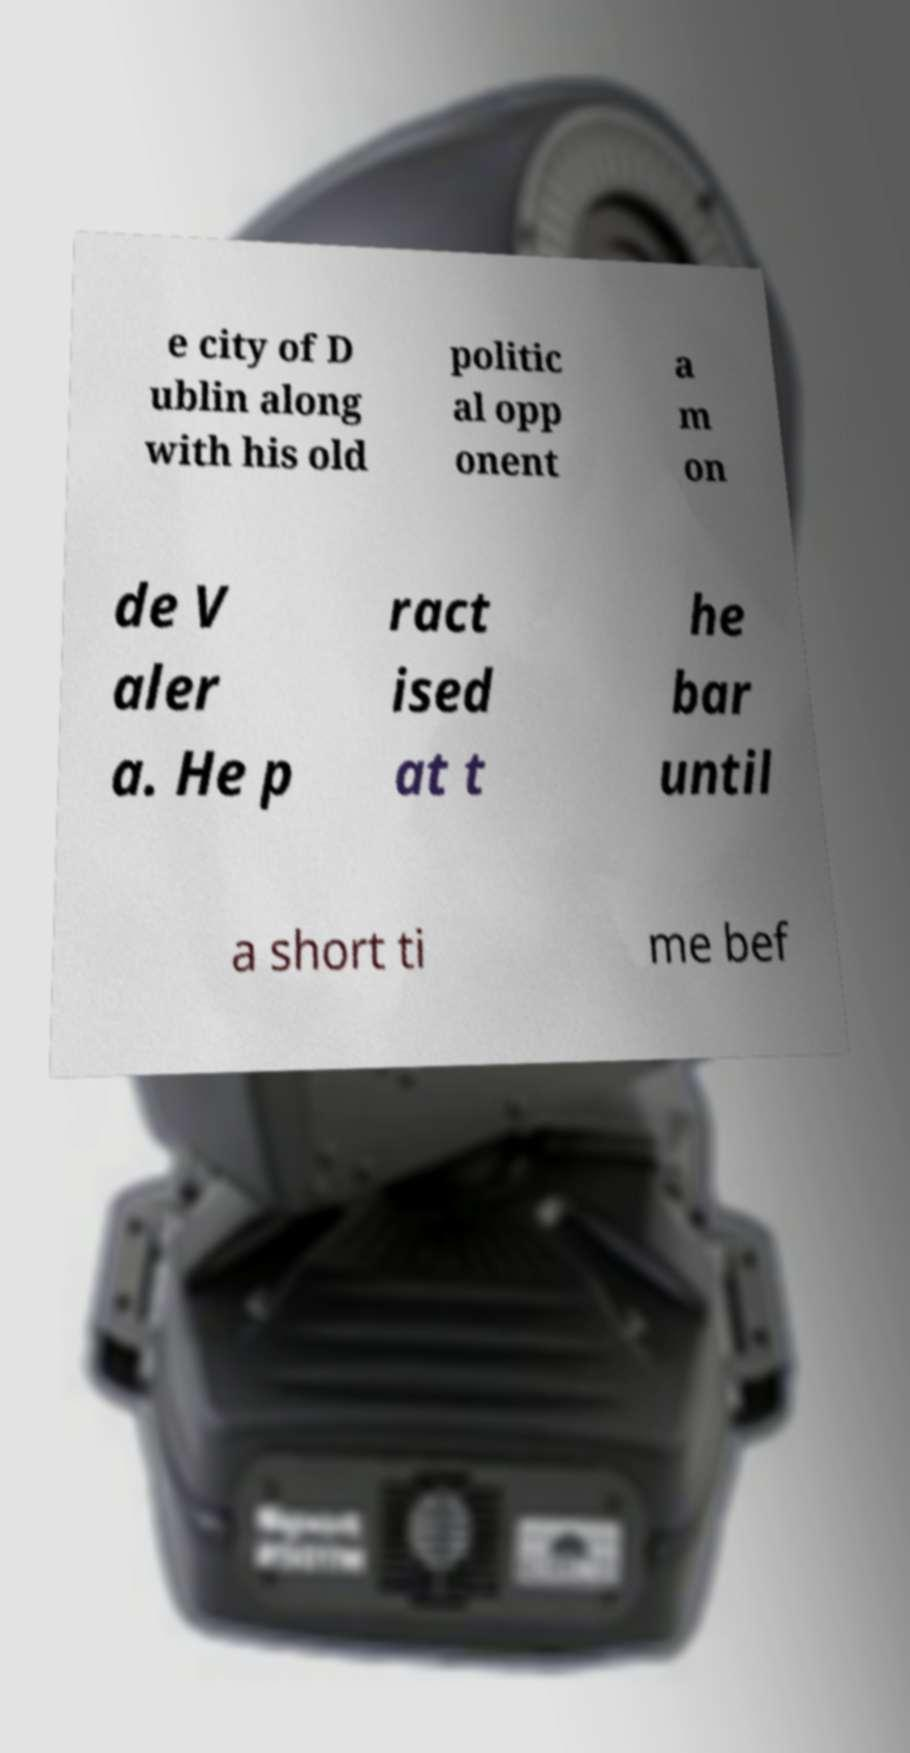There's text embedded in this image that I need extracted. Can you transcribe it verbatim? e city of D ublin along with his old politic al opp onent a m on de V aler a. He p ract ised at t he bar until a short ti me bef 